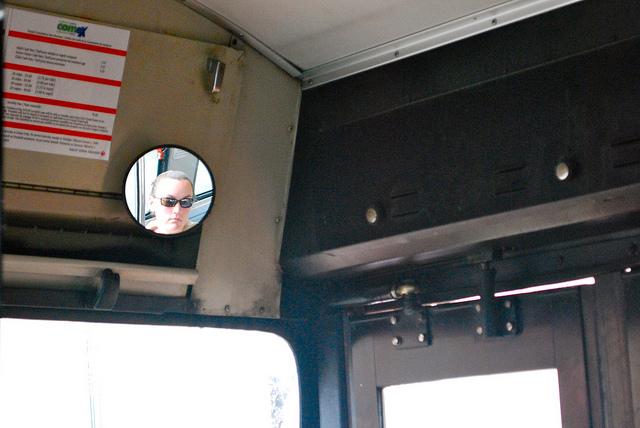Are they on a bus?
Concise answer only. Yes. Is there a face seen on the rearview mirror?
Be succinct. Yes. Is the woman wearing sunglasses?
Concise answer only. Yes. 